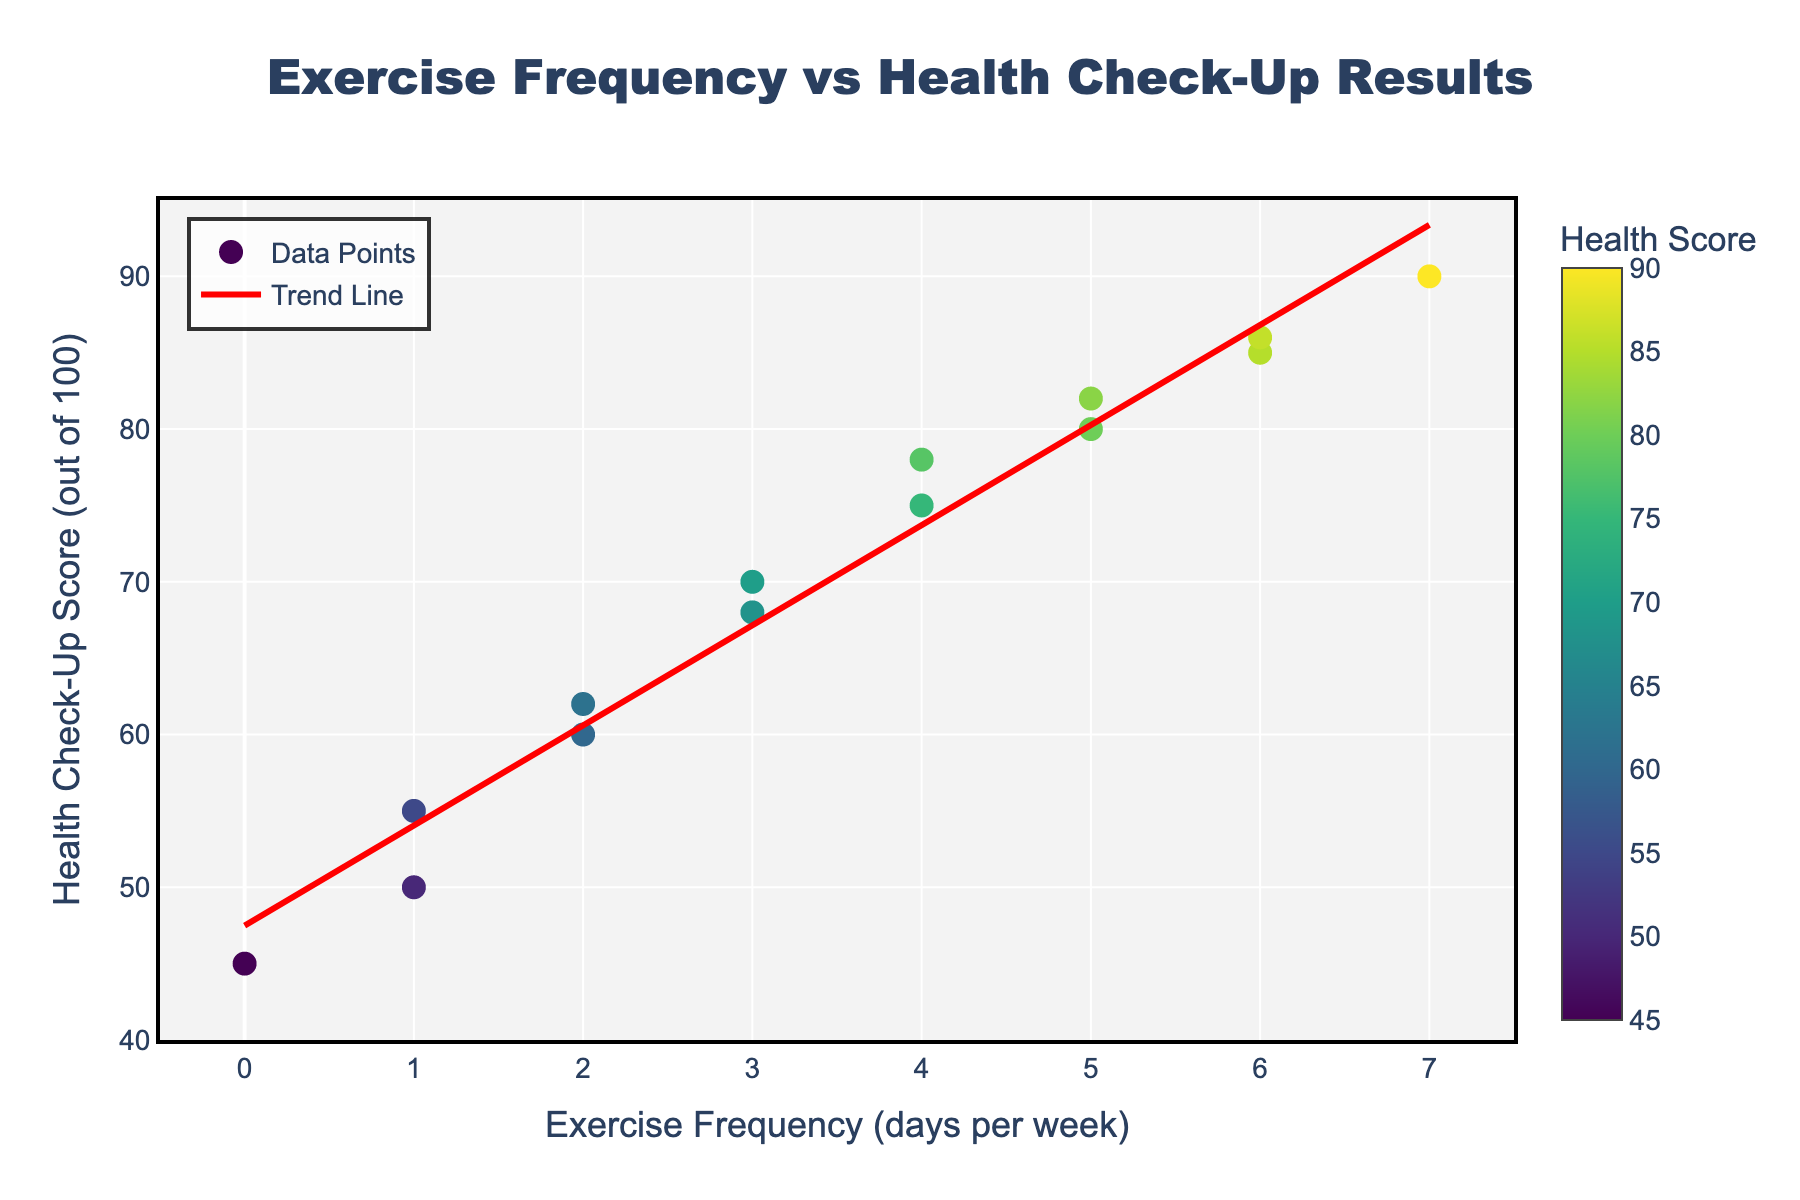What's the title of the figure? The title is located at the top of the figure and reads, "Exercise Frequency vs Health Check-Up Results".
Answer: Exercise Frequency vs Health Check-Up Results How many data points are in the scatter plot? Count the number of dots or markers visible in the scatter plot; there are 14 data points.
Answer: 14 What is the trend shown by the trend line? The trend line is a straight line (linear fit) that slopes upwards, indicating a positive relationship between exercise frequency and health check-up score.
Answer: Positive What's the health check-up score for someone who exercises 3 days per week? Find the marker that aligns with "3 days per week" on the x-axis and look up to its corresponding y-axis value; it reads around 68 and 70.
Answer: 68-70 What's the range of exercise frequency in the data? Look at the x-axis to see the lowest and highest values; the frequency ranges from 0 to 7 days per week.
Answer: 0-7 What's the average health check-up score for someone who exercises 5 or more days per week? Identify the data points for 5, 6, and 7 days per week, then find the scores for these points: (80, 82, 85, 86, 90). Sum them up and divide by the number of points, (80 + 82 + 85 + 86 + 90) / 5 = 84.6.
Answer: 84.6 Compare the health check-up scores for someone who exercises 1 day per week and 4 days per week. Identify the data points corresponding to 1 day per week (50 and 55) and 4 days per week (75 and 78). The scores for 4 days per week are higher both times.
Answer: Higher for 4 days per week What's the lowest health check-up score recorded, and how often does that individual exercise? Find the smallest y-value on the scatter plot which is 45, then check the corresponding x-value, which indicates 0 days of exercise per week.
Answer: 45, 0 days What is the slope of the trend line? The trend line is given by the fitted polynomial equation on the plot. By estimating from the trend line, the slope is around 7.2.
Answer: ~7.2 What color scheme is used for the scatter points and what does the color represent? The colors range from light green to dark green to purple; they represent the health check-up score, with a color bar indicating higher scores are darker.
Answer: Viridis, Health Score 